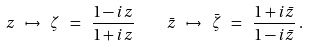Convert formula to latex. <formula><loc_0><loc_0><loc_500><loc_500>z \ \mapsto \ \zeta \ = \ \frac { 1 - i z } { 1 + i z } \quad \bar { z } \ \mapsto \ \bar { \zeta } \ = \ \frac { 1 + i \bar { z } } { 1 - i \bar { z } } \, .</formula> 